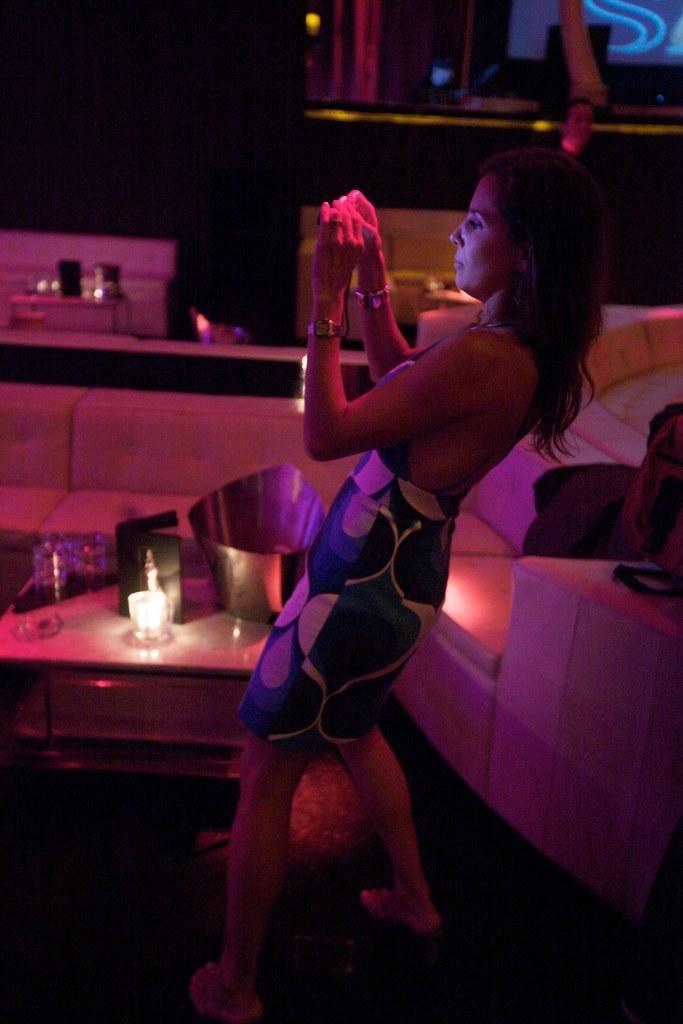Describe this image in one or two sentences. In the center of the image we can see a lady standing. On the right there is a sofa and we can see a bag placed on the sofa. At the bottom there is a stand and we can see a jug and candles placed on the stand. In the background there is a wall and a wall frame. 